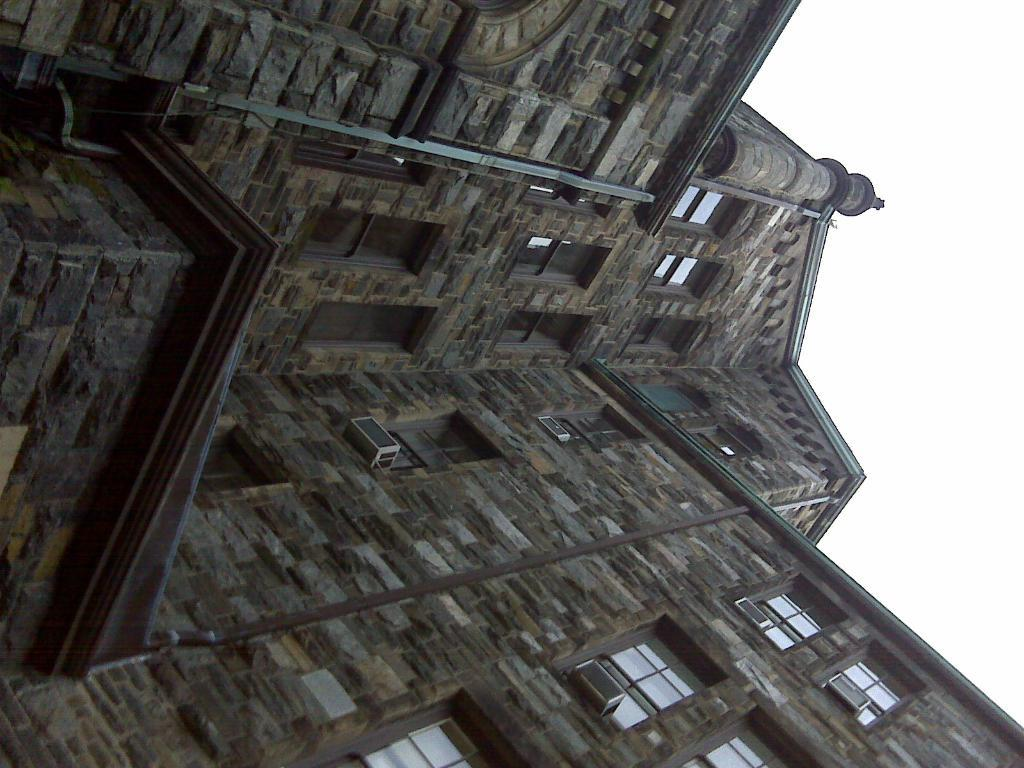What type of structure is in the image? There is a building in the image. What feature can be seen on the building? There are windows in the building. What additional equipment is present in the image? AC condensers are present in the image. What part of the natural environment is visible in the image? The sky is visible on the right side of the image. What type of tree can be seen growing inside the building in the image? There is no tree present inside the building in the image. 